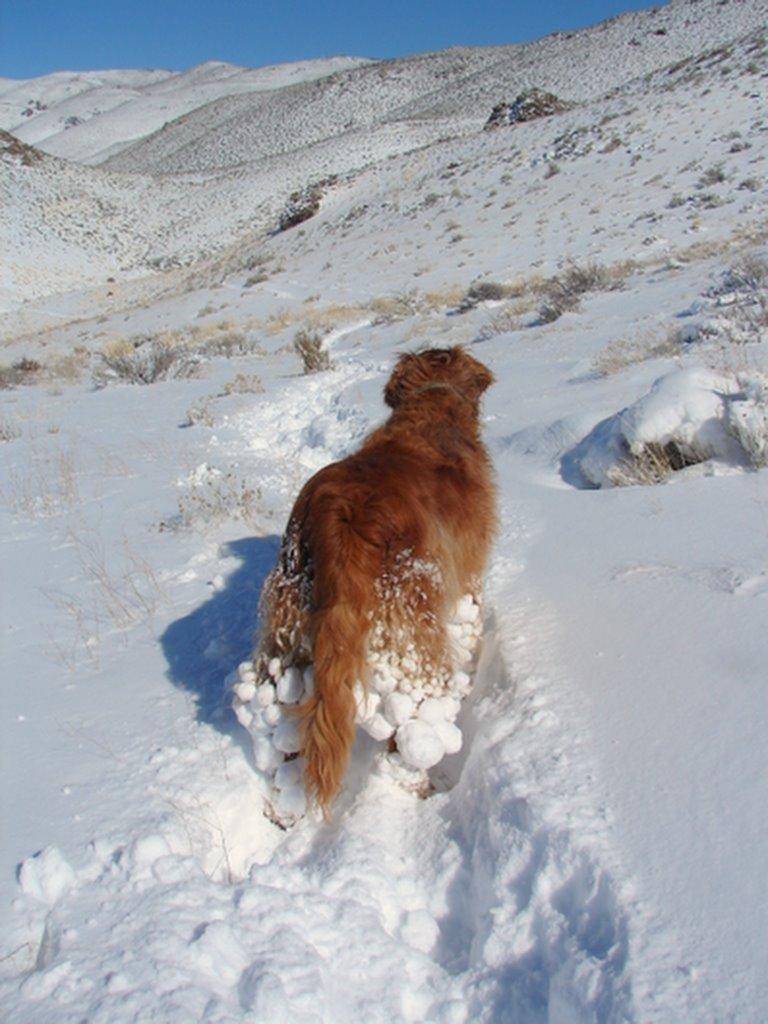Describe this image in one or two sentences. This is the picture of a mountain. In this image there is an animal standing. At the back there are plants. At the top there is sky. At the bottom there is snow. 